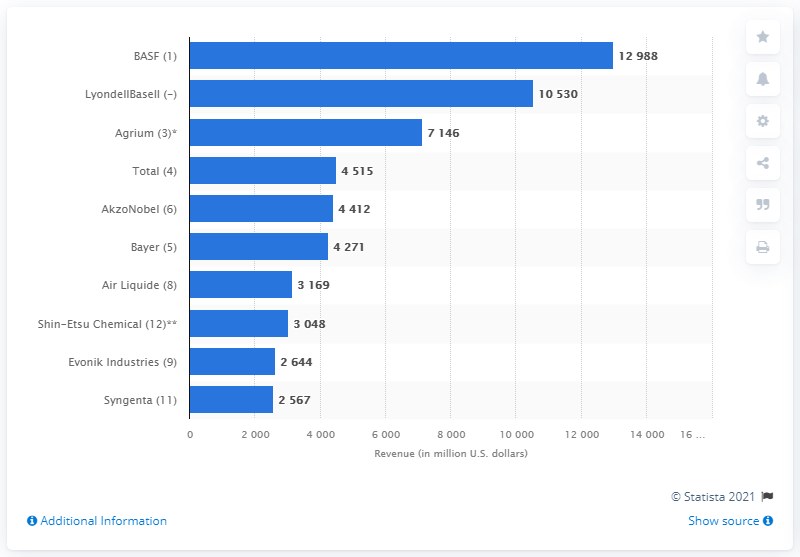Draw attention to some important aspects in this diagram. The total revenue of the BASF Group in the United States in 2009 was 12,988. 